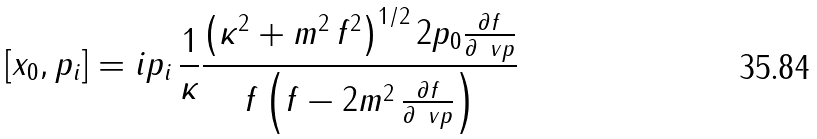<formula> <loc_0><loc_0><loc_500><loc_500>[ x _ { 0 } , p _ { i } ] = i p _ { i } \, \frac { 1 } { \kappa } \frac { \left ( \kappa ^ { 2 } + m ^ { 2 } \, f ^ { 2 } \right ) ^ { 1 / 2 } 2 p _ { 0 } \frac { \partial f } { \partial \ v p } } { f \left ( f - 2 m ^ { 2 } \, \frac { \partial f } { \partial \ v p } \right ) }</formula> 